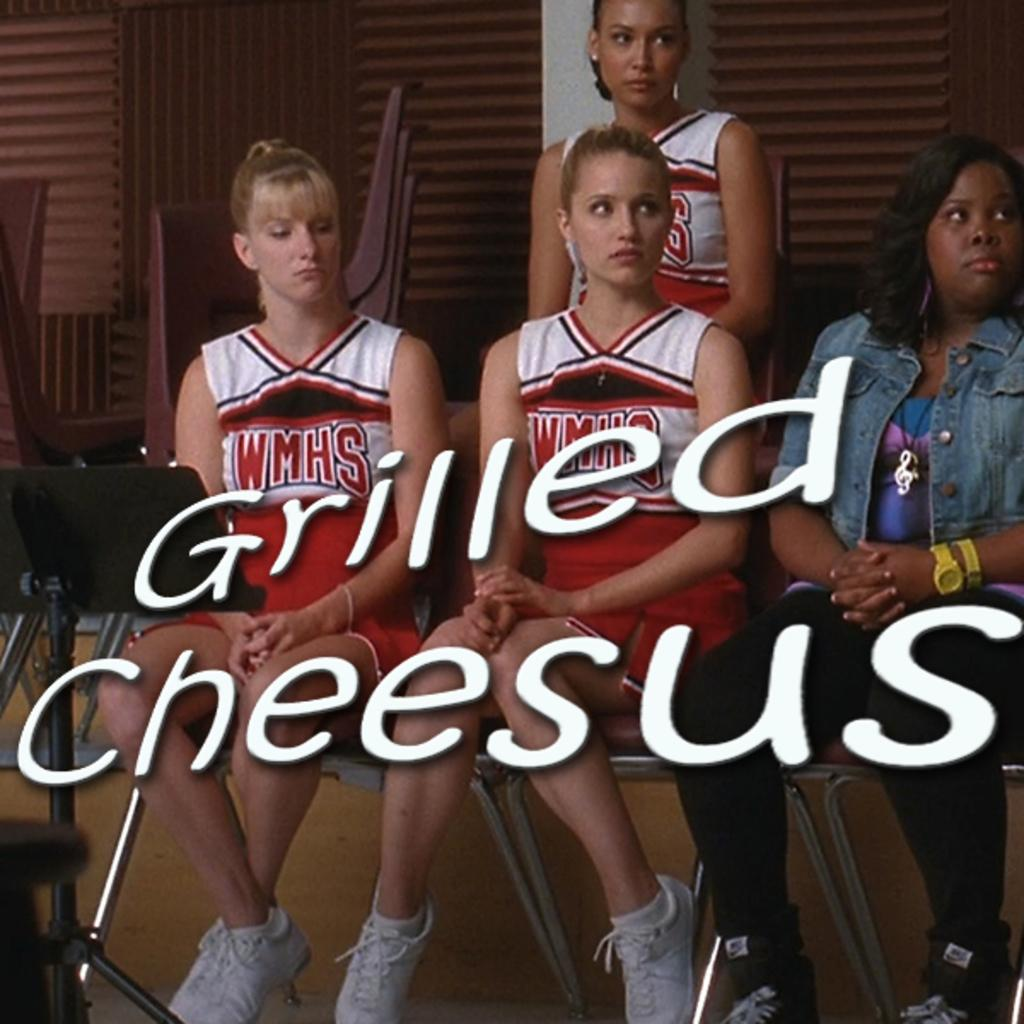<image>
Summarize the visual content of the image. A group of cheerleaders are sitting in chairs with text that says Grilled Cheesus. 